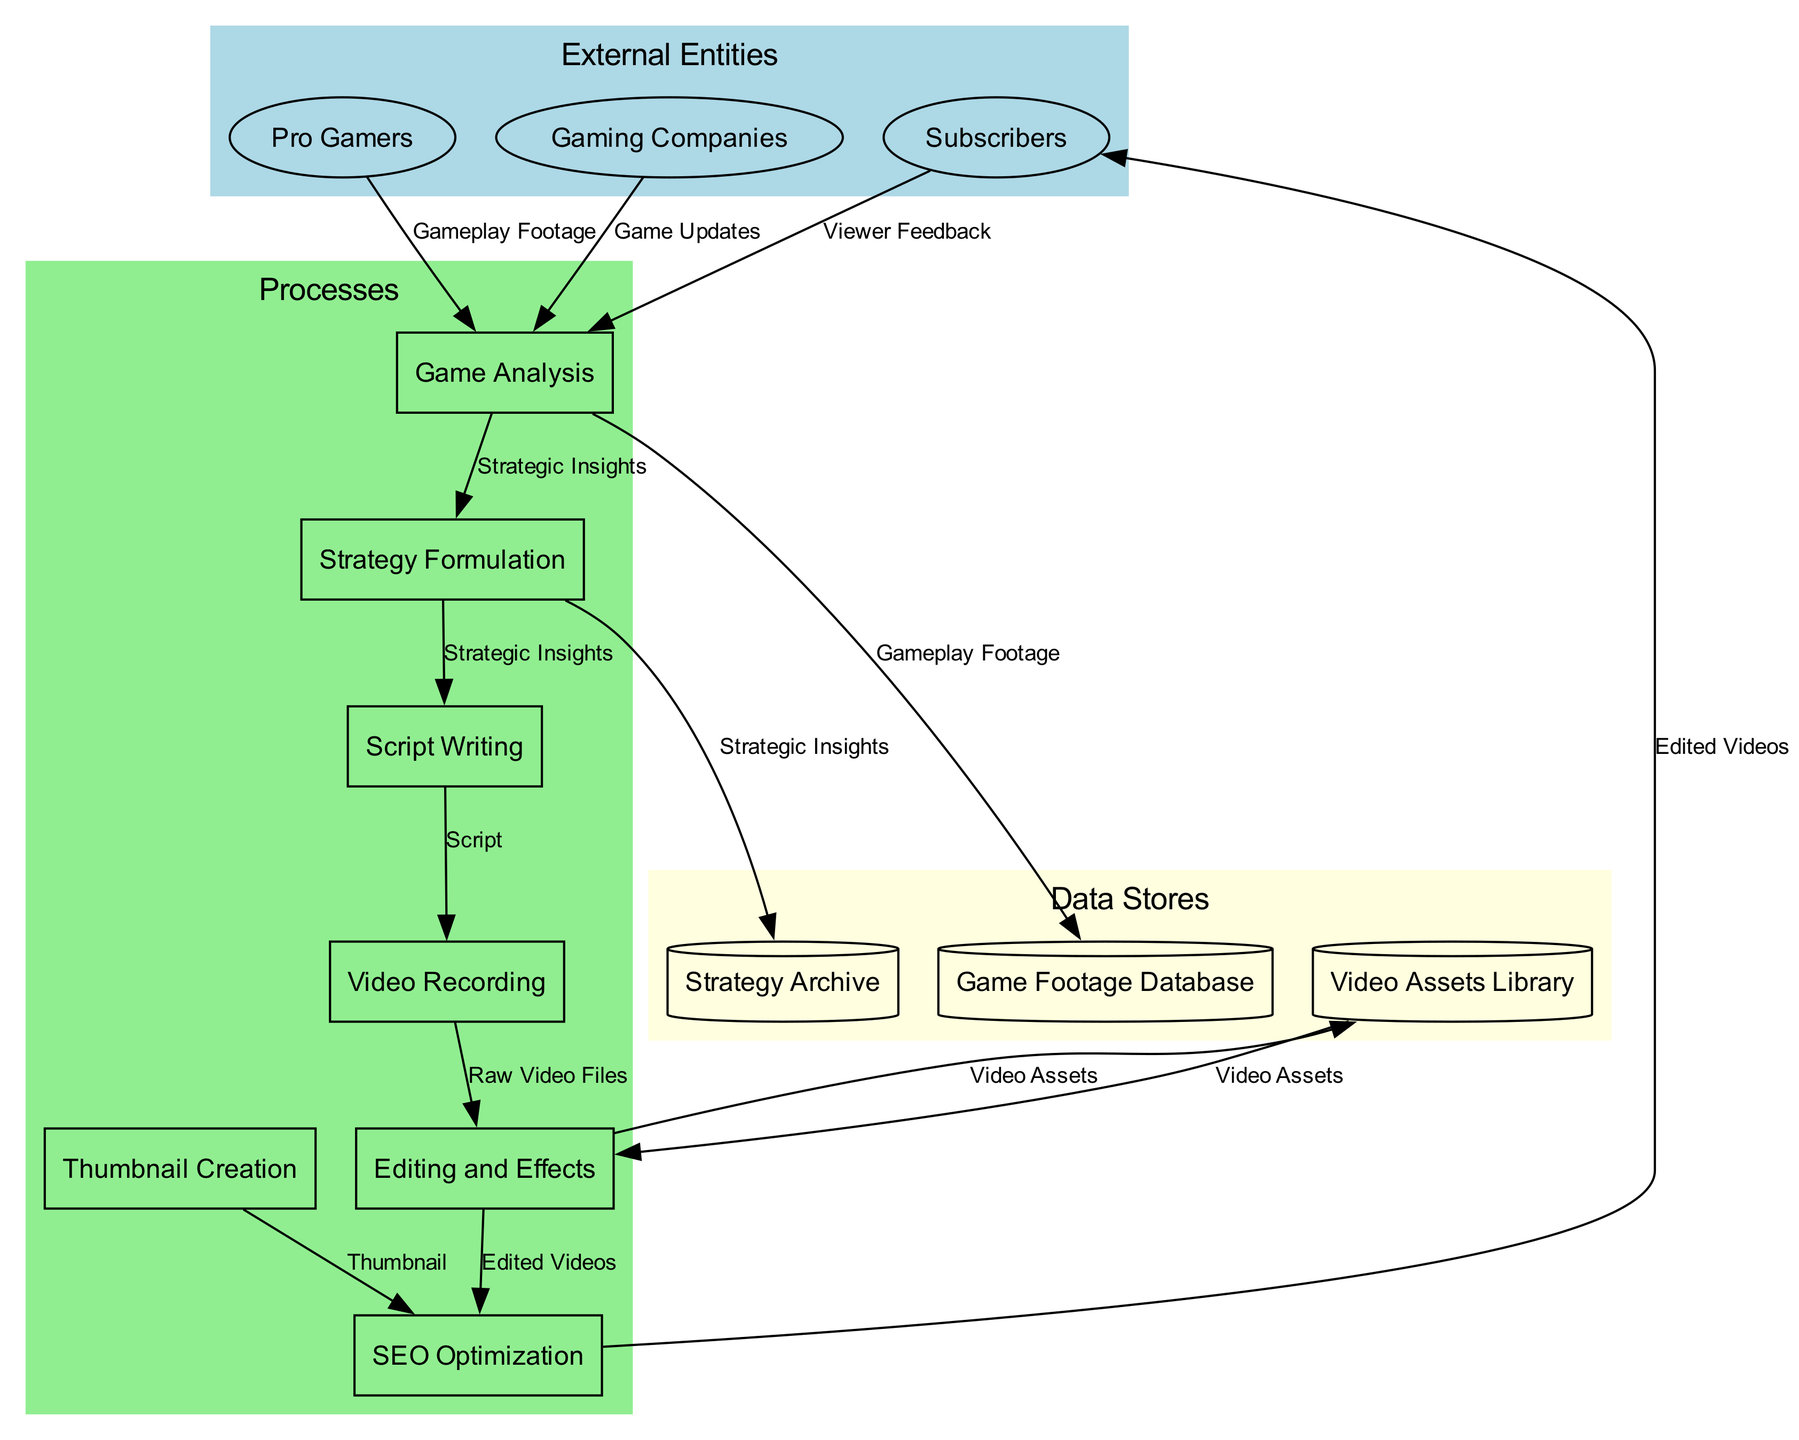What are the external entities in the diagram? The external entities are listed at the top of the diagram. They include Pro Gamers, Subscribers, and Gaming Companies.
Answer: Pro Gamers, Subscribers, Gaming Companies How many processes are represented in the diagram? The diagram shows a total of six processes, which are Game Analysis, Strategy Formulation, Script Writing, Video Recording, Editing and Effects, and SEO Optimization.
Answer: Six Which process receives Gameplay Footage as input? By following the flow of information, Gameplay Footage flows from Pro Gamers and Gaming Companies to the Game Analysis process.
Answer: Game Analysis What is the output of the Editing and Effects process? The output of the Editing and Effects process is the Edited Videos, which flow to the SEO Optimization process next.
Answer: Edited Videos How does Viewer Feedback influence the process? Viewer Feedback flows from Subscribers to the Game Analysis process, indicating that it directly influences game analysis and subsequently affects the overall strategy development.
Answer: Game Analysis What data store is linked to the Strategy Formulation process? The Strategy Formulation process connects with the Strategy Archive, where strategic insights are stored.
Answer: Strategy Archive Which process directly creates the Thumbnail? The Thumbnail is created during the Thumbnail Creation process, which then feeds into the SEO Optimization process for better visibility.
Answer: Thumbnail Creation What type of feedback does Subscribers provide to the Game Analysis process? Subscribers provide Viewer Feedback to the Game Analysis process, which is utilized for refining strategies based on audience engagement.
Answer: Viewer Feedback How many data stores are there in total? The total number of data stores in the diagram is three, which are Game Footage Database, Strategy Archive, and Video Assets Library.
Answer: Three 